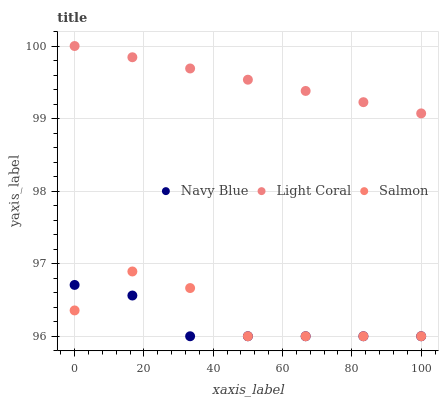Does Navy Blue have the minimum area under the curve?
Answer yes or no. Yes. Does Light Coral have the maximum area under the curve?
Answer yes or no. Yes. Does Salmon have the minimum area under the curve?
Answer yes or no. No. Does Salmon have the maximum area under the curve?
Answer yes or no. No. Is Light Coral the smoothest?
Answer yes or no. Yes. Is Salmon the roughest?
Answer yes or no. Yes. Is Navy Blue the smoothest?
Answer yes or no. No. Is Navy Blue the roughest?
Answer yes or no. No. Does Navy Blue have the lowest value?
Answer yes or no. Yes. Does Light Coral have the highest value?
Answer yes or no. Yes. Does Salmon have the highest value?
Answer yes or no. No. Is Salmon less than Light Coral?
Answer yes or no. Yes. Is Light Coral greater than Navy Blue?
Answer yes or no. Yes. Does Navy Blue intersect Salmon?
Answer yes or no. Yes. Is Navy Blue less than Salmon?
Answer yes or no. No. Is Navy Blue greater than Salmon?
Answer yes or no. No. Does Salmon intersect Light Coral?
Answer yes or no. No. 